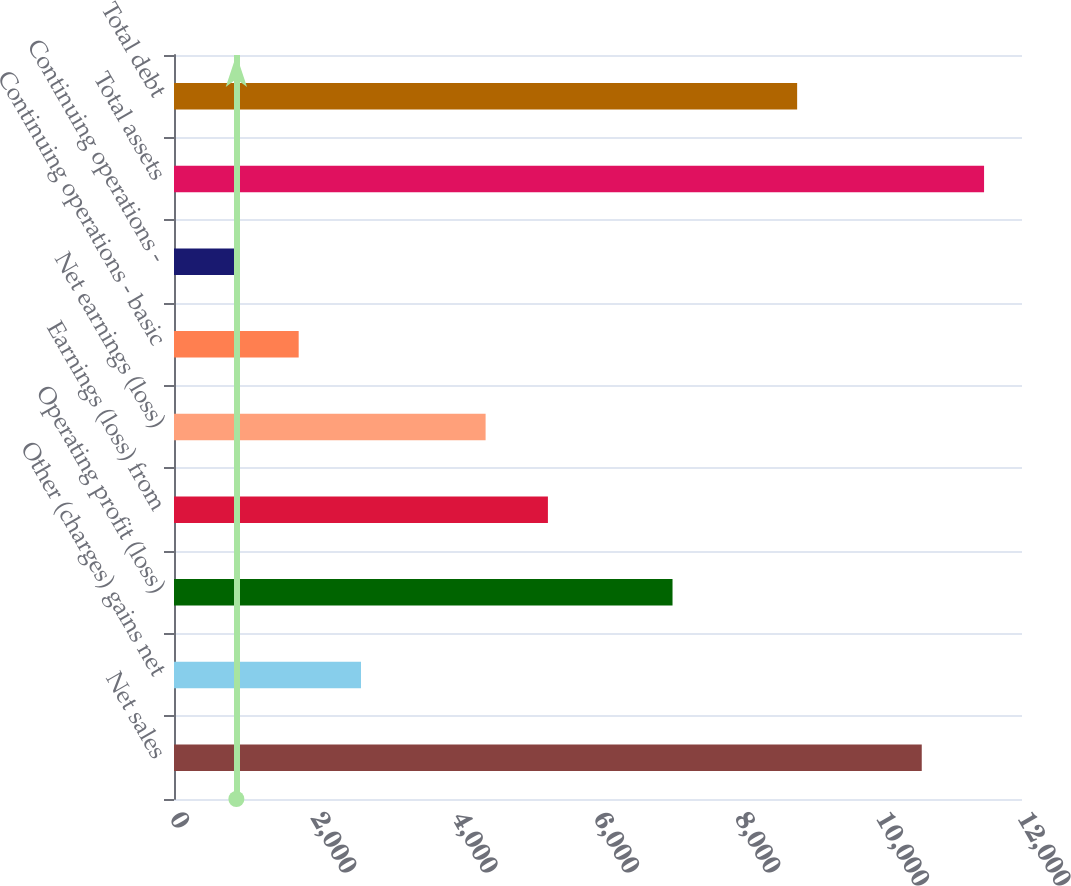Convert chart. <chart><loc_0><loc_0><loc_500><loc_500><bar_chart><fcel>Net sales<fcel>Other (charges) gains net<fcel>Operating profit (loss)<fcel>Earnings (loss) from<fcel>Net earnings (loss)<fcel>Continuing operations - basic<fcel>Continuing operations -<fcel>Total assets<fcel>Total debt<nl><fcel>10581.5<fcel>2646.06<fcel>7054.61<fcel>5291.19<fcel>4409.48<fcel>1764.35<fcel>882.64<fcel>11463.2<fcel>8818.03<nl></chart> 